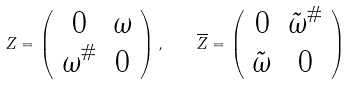<formula> <loc_0><loc_0><loc_500><loc_500>Z = \left ( \begin{array} { c c } 0 & \omega \\ \omega ^ { \# } & 0 \end{array} \right ) , \quad \overline { Z } = \left ( \begin{array} { c c } 0 & { \tilde { \omega } } ^ { \# } \\ { \tilde { \omega } } & 0 \end{array} \right )</formula> 